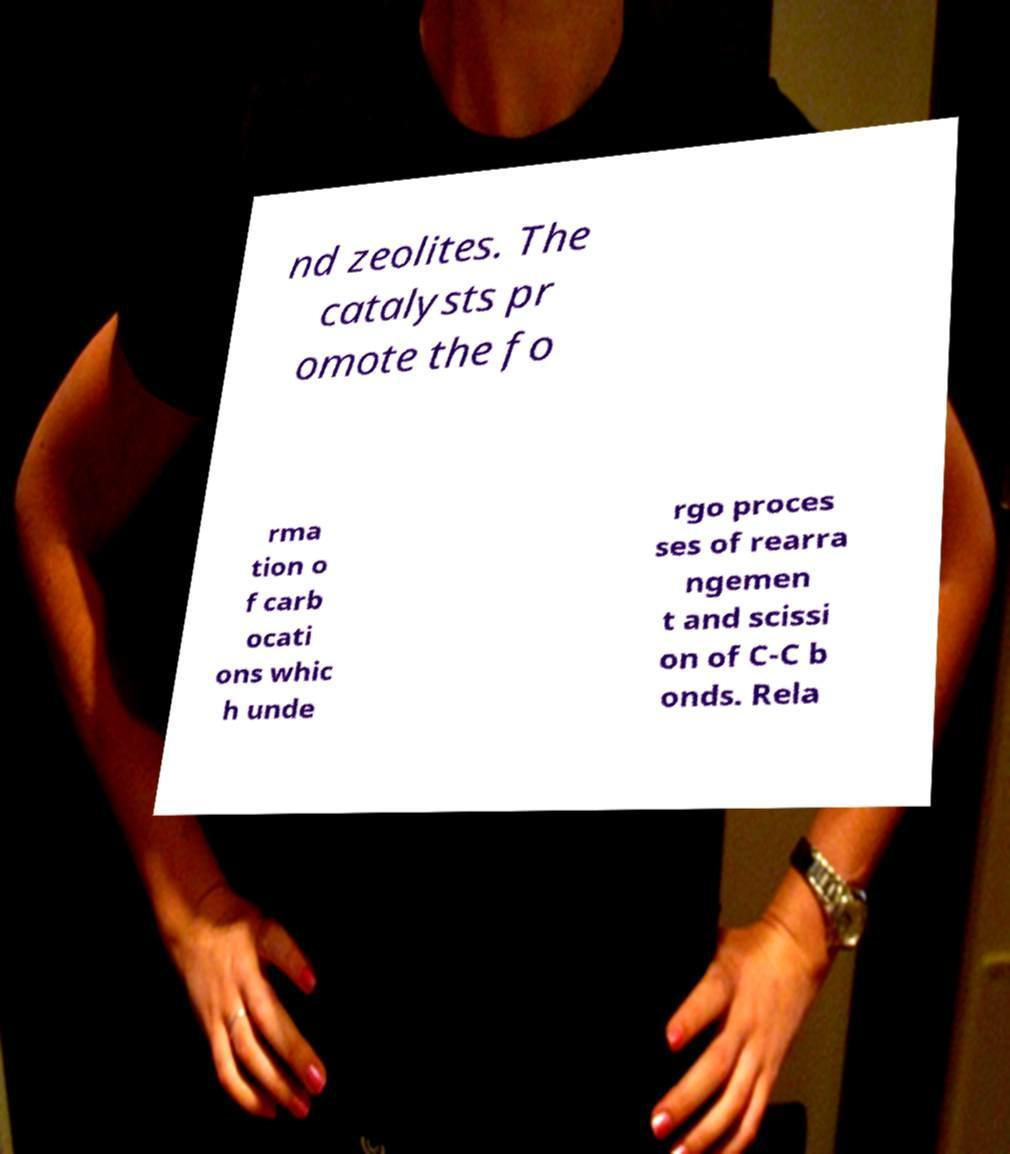Could you assist in decoding the text presented in this image and type it out clearly? nd zeolites. The catalysts pr omote the fo rma tion o f carb ocati ons whic h unde rgo proces ses of rearra ngemen t and scissi on of C-C b onds. Rela 